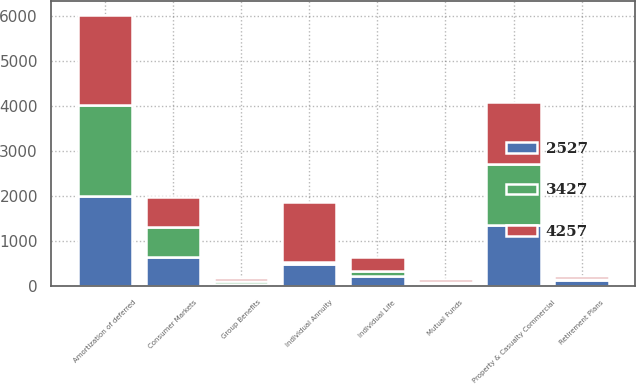<chart> <loc_0><loc_0><loc_500><loc_500><stacked_bar_chart><ecel><fcel>Amortization of deferred<fcel>Property & Casualty Commercial<fcel>Group Benefits<fcel>Consumer Markets<fcel>Individual Annuity<fcel>Individual Life<fcel>Retirement Plans<fcel>Mutual Funds<nl><fcel>2527<fcel>2011<fcel>1356<fcel>55<fcel>639<fcel>483<fcel>221<fcel>134<fcel>47<nl><fcel>3427<fcel>2010<fcel>1353<fcel>61<fcel>667<fcel>56<fcel>119<fcel>27<fcel>51<nl><fcel>4257<fcel>2009<fcel>1393<fcel>61<fcel>674<fcel>1339<fcel>314<fcel>56<fcel>50<nl></chart> 